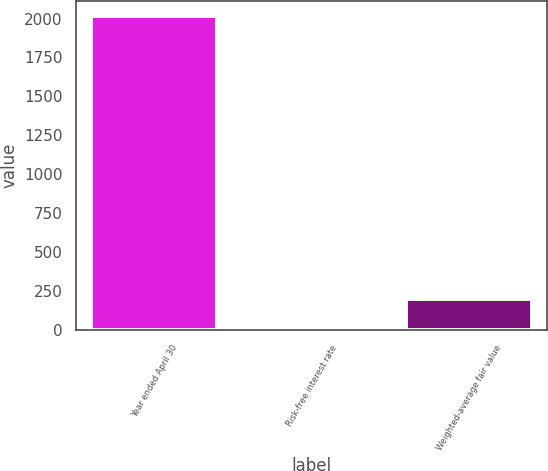Convert chart. <chart><loc_0><loc_0><loc_500><loc_500><bar_chart><fcel>Year ended April 30<fcel>Risk-free interest rate<fcel>Weighted-average fair value<nl><fcel>2014<fcel>0.61<fcel>201.95<nl></chart> 